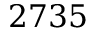<formula> <loc_0><loc_0><loc_500><loc_500>2 7 3 5</formula> 